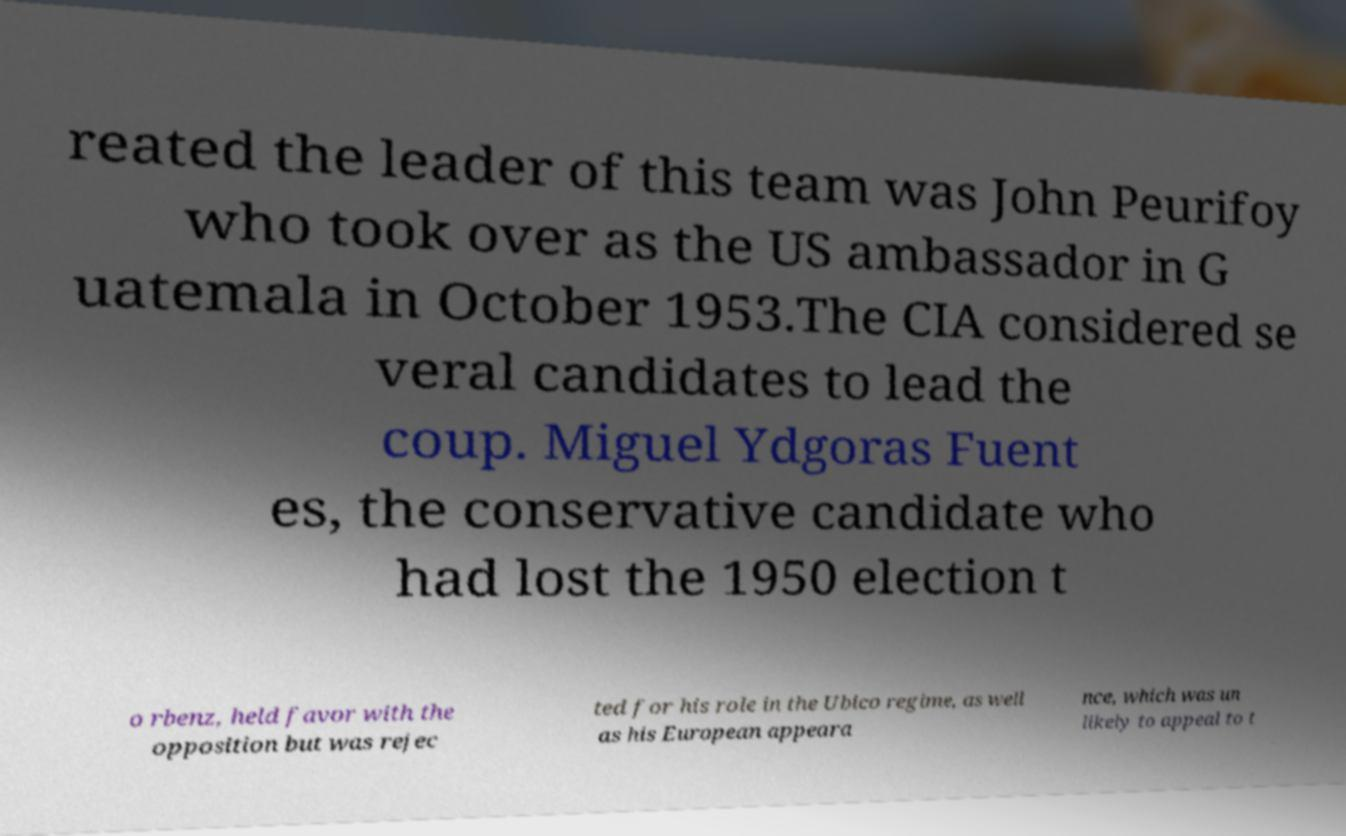There's text embedded in this image that I need extracted. Can you transcribe it verbatim? reated the leader of this team was John Peurifoy who took over as the US ambassador in G uatemala in October 1953.The CIA considered se veral candidates to lead the coup. Miguel Ydgoras Fuent es, the conservative candidate who had lost the 1950 election t o rbenz, held favor with the opposition but was rejec ted for his role in the Ubico regime, as well as his European appeara nce, which was un likely to appeal to t 